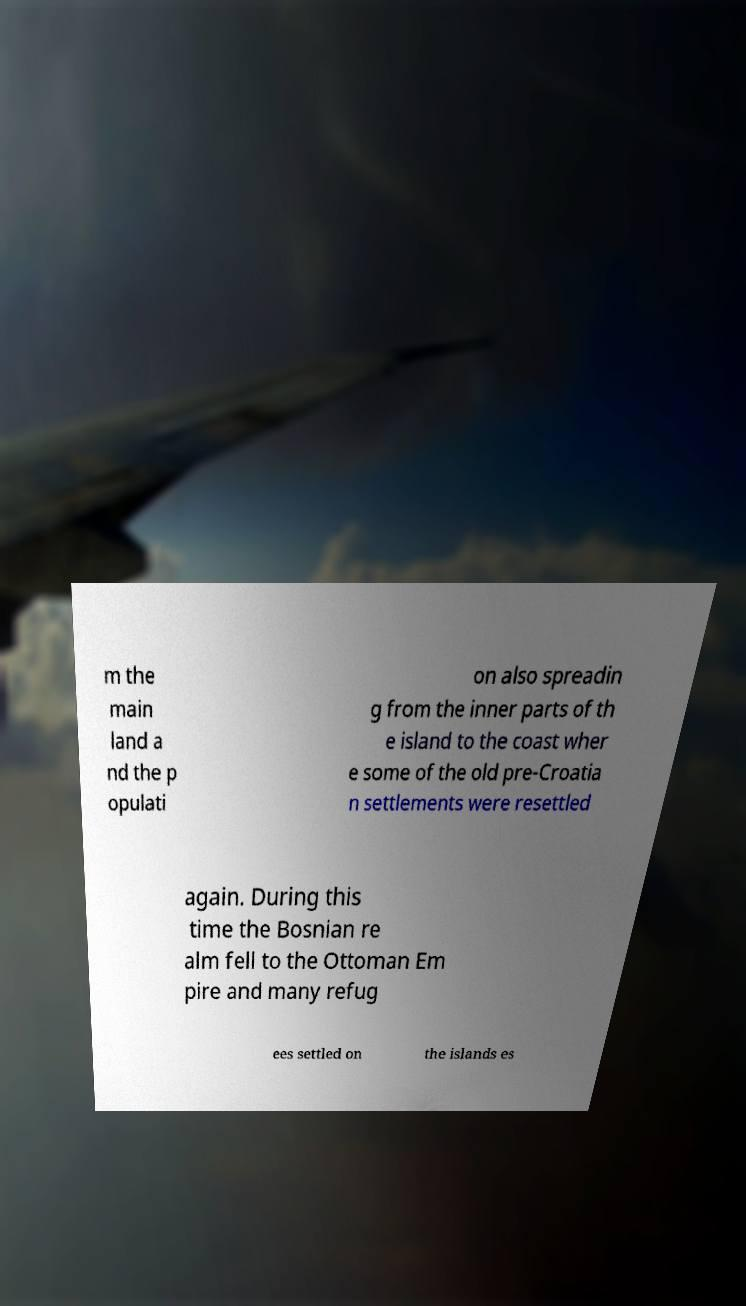There's text embedded in this image that I need extracted. Can you transcribe it verbatim? m the main land a nd the p opulati on also spreadin g from the inner parts of th e island to the coast wher e some of the old pre-Croatia n settlements were resettled again. During this time the Bosnian re alm fell to the Ottoman Em pire and many refug ees settled on the islands es 